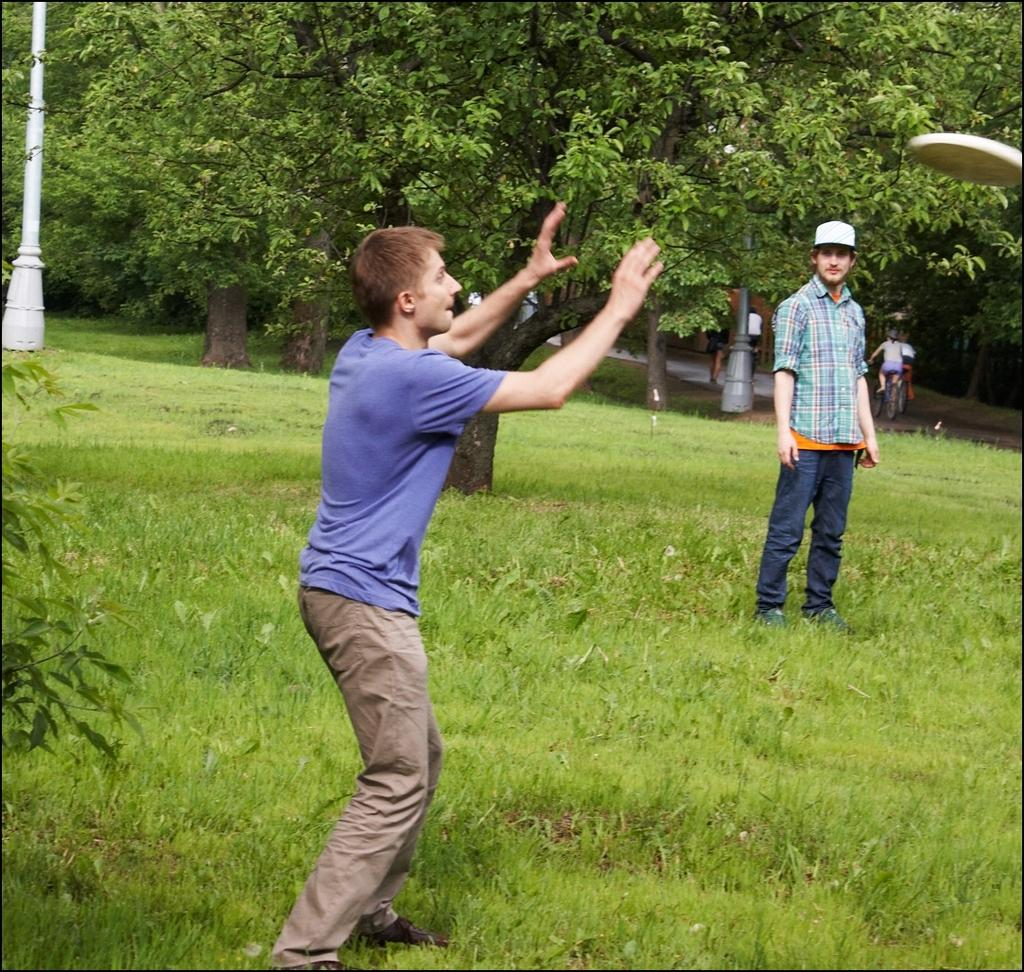What type of vegetation can be seen in the image? There are trees in the image. Who or what is present in the image? There are people in the image. What is the ground covered with in the image? There is grass in the image. What object can be seen in the image that is round and flat? There is a disc in the image. What mode of transportation can be seen in the background of the image? There is a bicycle in the background of the image. How many mice are playing basketball on the disc in the image? There are no mice or basketballs present in the image. What type of food is the cook preparing in the image? There is no cook or food preparation visible in the image. 